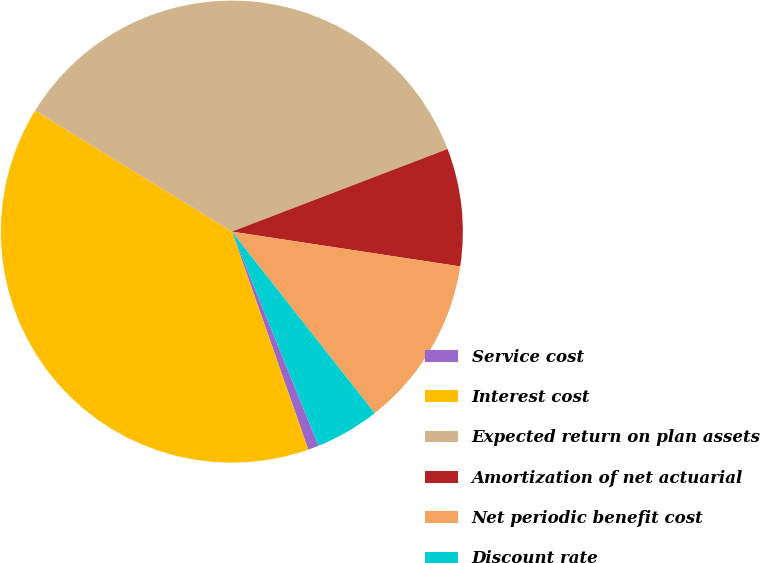<chart> <loc_0><loc_0><loc_500><loc_500><pie_chart><fcel>Service cost<fcel>Interest cost<fcel>Expected return on plan assets<fcel>Amortization of net actuarial<fcel>Net periodic benefit cost<fcel>Discount rate<nl><fcel>0.75%<fcel>39.14%<fcel>35.4%<fcel>8.23%<fcel>11.98%<fcel>4.49%<nl></chart> 